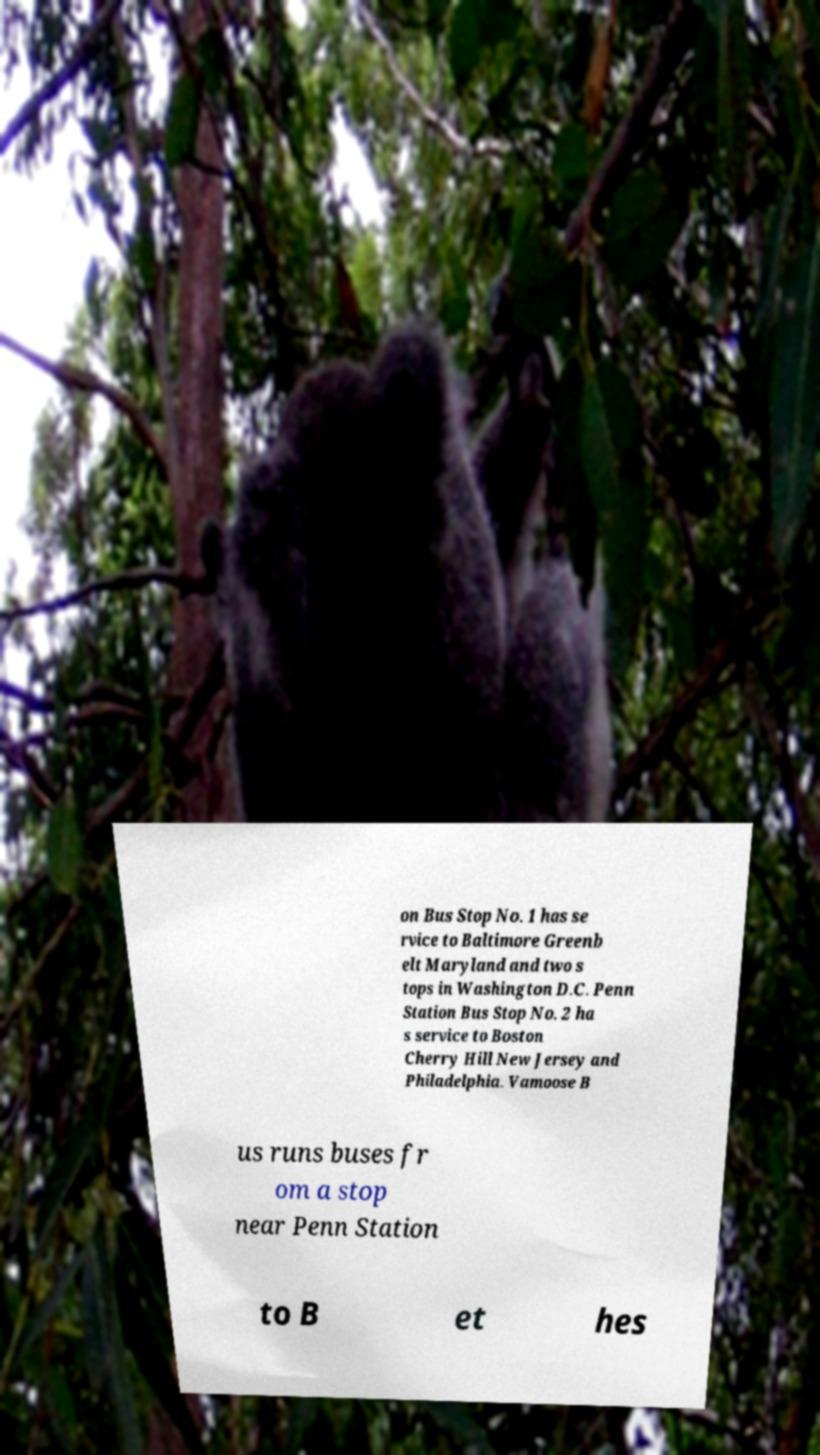Please read and relay the text visible in this image. What does it say? on Bus Stop No. 1 has se rvice to Baltimore Greenb elt Maryland and two s tops in Washington D.C. Penn Station Bus Stop No. 2 ha s service to Boston Cherry Hill New Jersey and Philadelphia. Vamoose B us runs buses fr om a stop near Penn Station to B et hes 